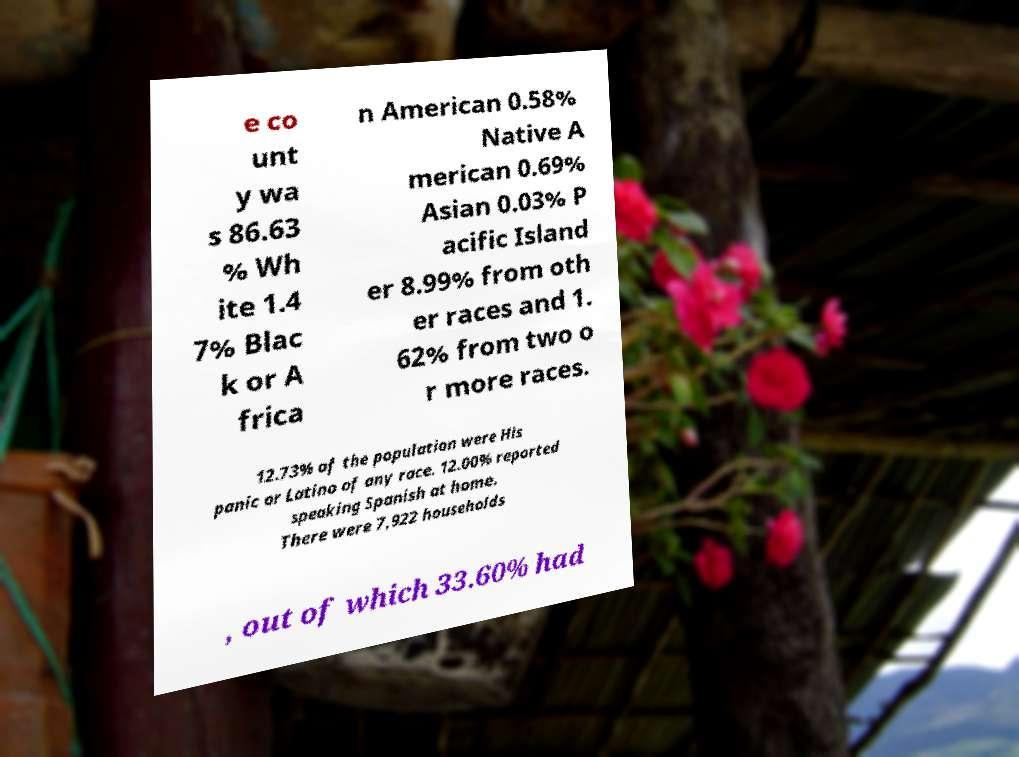For documentation purposes, I need the text within this image transcribed. Could you provide that? e co unt y wa s 86.63 % Wh ite 1.4 7% Blac k or A frica n American 0.58% Native A merican 0.69% Asian 0.03% P acific Island er 8.99% from oth er races and 1. 62% from two o r more races. 12.73% of the population were His panic or Latino of any race. 12.00% reported speaking Spanish at home. There were 7,922 households , out of which 33.60% had 